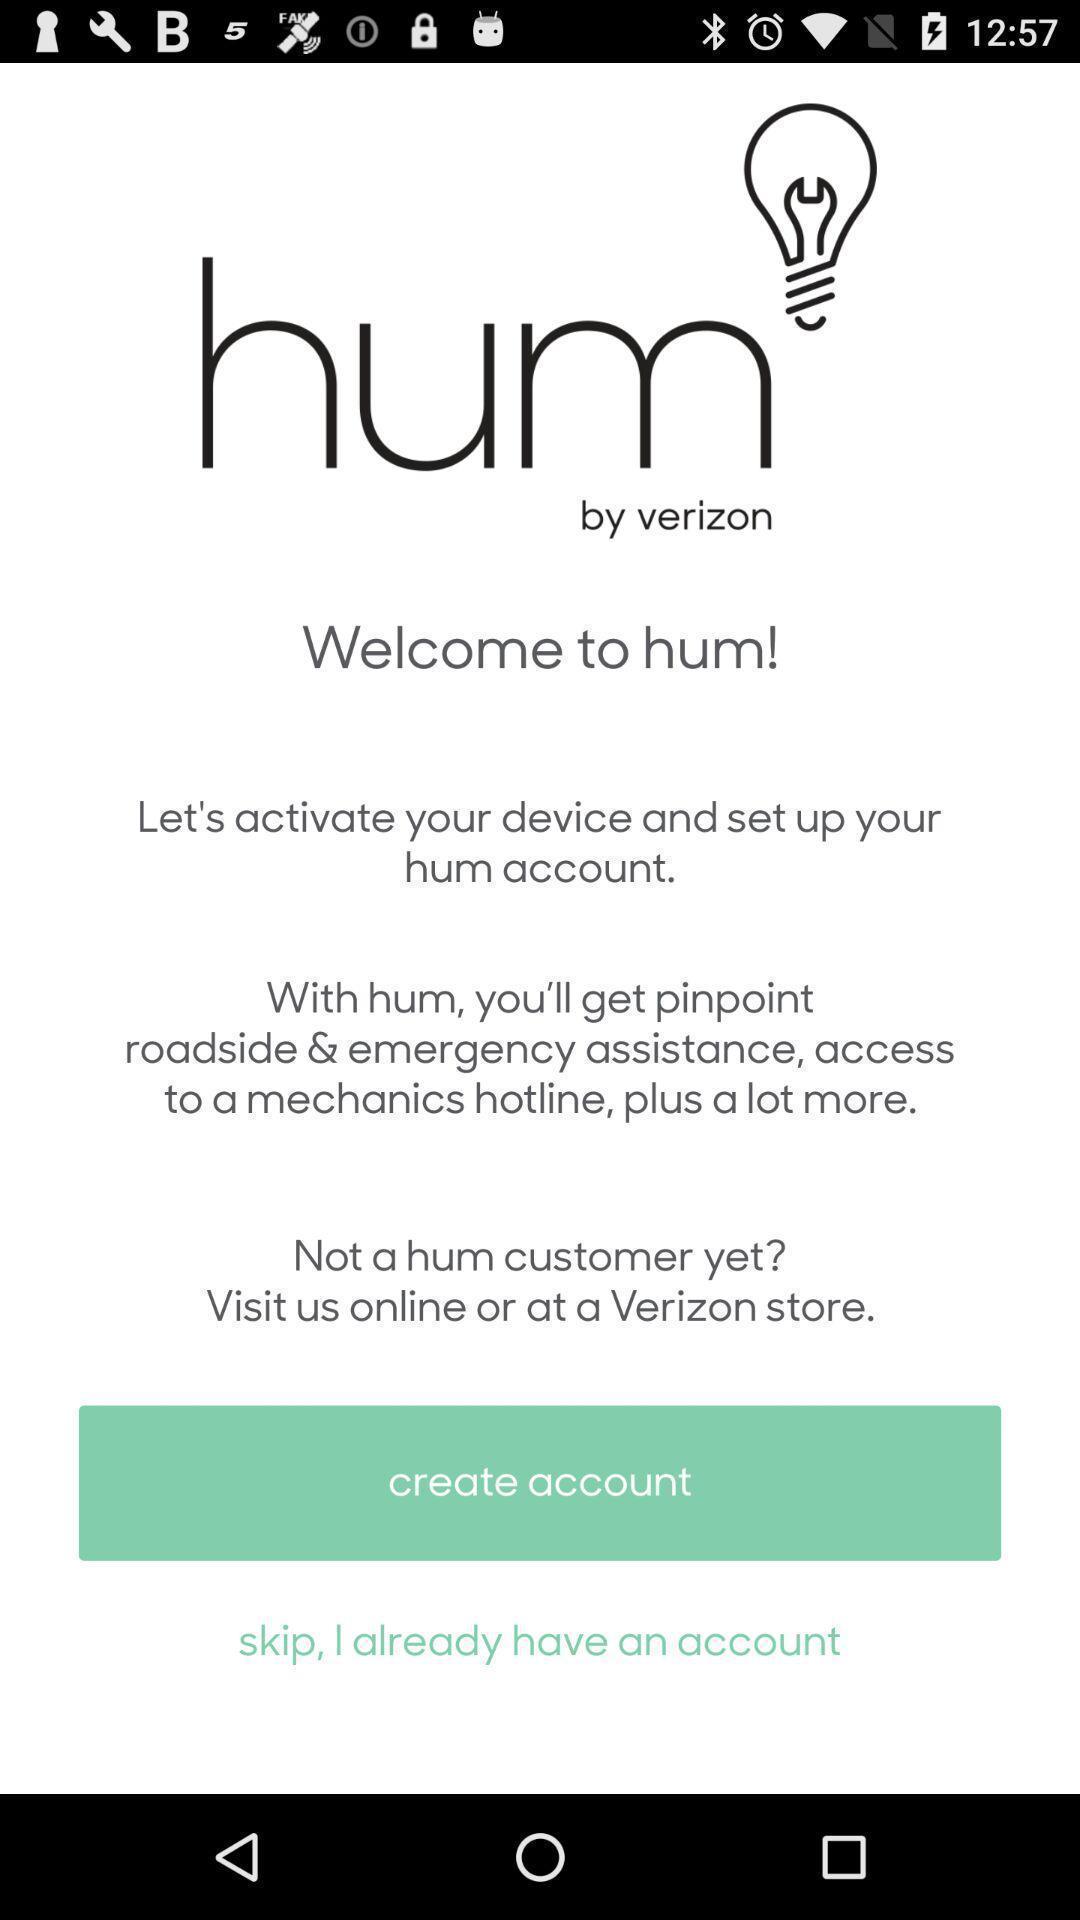Provide a description of this screenshot. Welcome page to the application. 